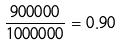Convert formula to latex. <formula><loc_0><loc_0><loc_500><loc_500>\frac { 9 0 0 0 0 0 } { 1 0 0 0 0 0 0 } = 0 . 9 0</formula> 